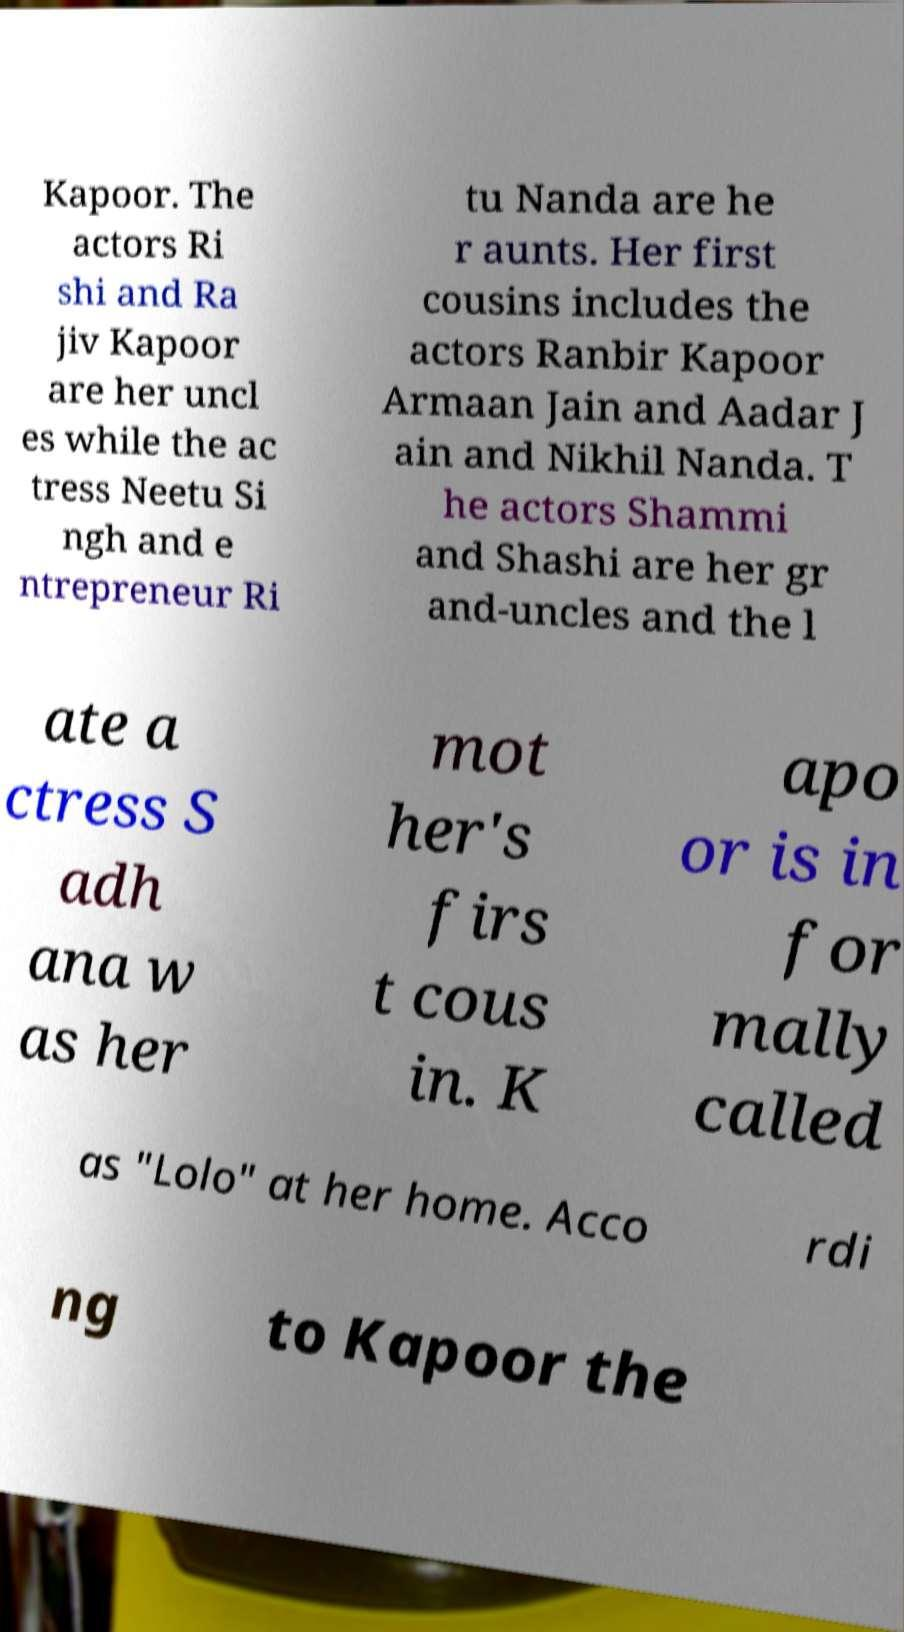Please read and relay the text visible in this image. What does it say? Kapoor. The actors Ri shi and Ra jiv Kapoor are her uncl es while the ac tress Neetu Si ngh and e ntrepreneur Ri tu Nanda are he r aunts. Her first cousins includes the actors Ranbir Kapoor Armaan Jain and Aadar J ain and Nikhil Nanda. T he actors Shammi and Shashi are her gr and-uncles and the l ate a ctress S adh ana w as her mot her's firs t cous in. K apo or is in for mally called as "Lolo" at her home. Acco rdi ng to Kapoor the 